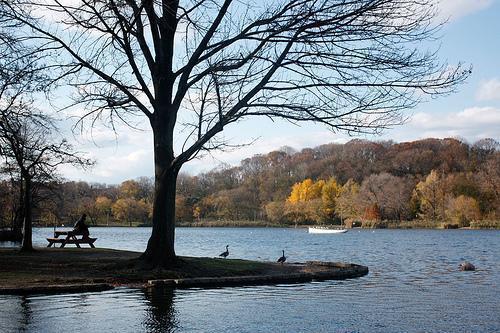How many animals are there?
Give a very brief answer. 2. How many people are there?
Give a very brief answer. 1. 